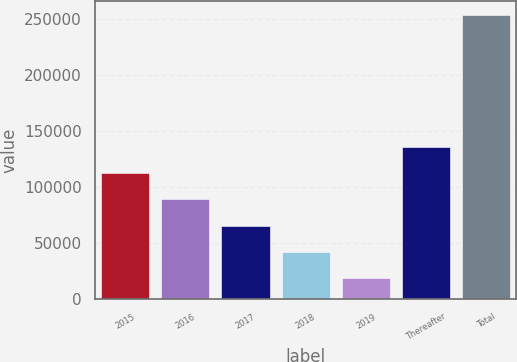Convert chart to OTSL. <chart><loc_0><loc_0><loc_500><loc_500><bar_chart><fcel>2015<fcel>2016<fcel>2017<fcel>2018<fcel>2019<fcel>Thereafter<fcel>Total<nl><fcel>112432<fcel>88914.9<fcel>65397.6<fcel>41880.3<fcel>18363<fcel>135950<fcel>253536<nl></chart> 